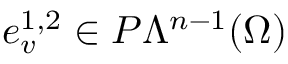<formula> <loc_0><loc_0><loc_500><loc_500>e _ { v } ^ { 1 , 2 } \in P \Lambda ^ { n - 1 } ( \Omega )</formula> 